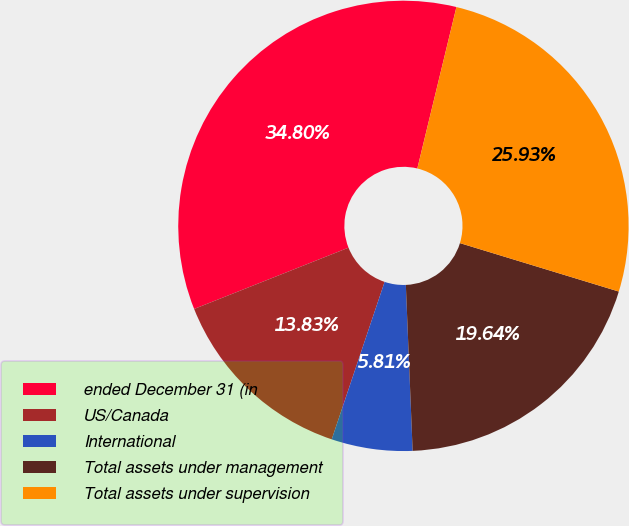Convert chart to OTSL. <chart><loc_0><loc_0><loc_500><loc_500><pie_chart><fcel>ended December 31 (in<fcel>US/Canada<fcel>International<fcel>Total assets under management<fcel>Total assets under supervision<nl><fcel>34.8%<fcel>13.83%<fcel>5.81%<fcel>19.64%<fcel>25.93%<nl></chart> 